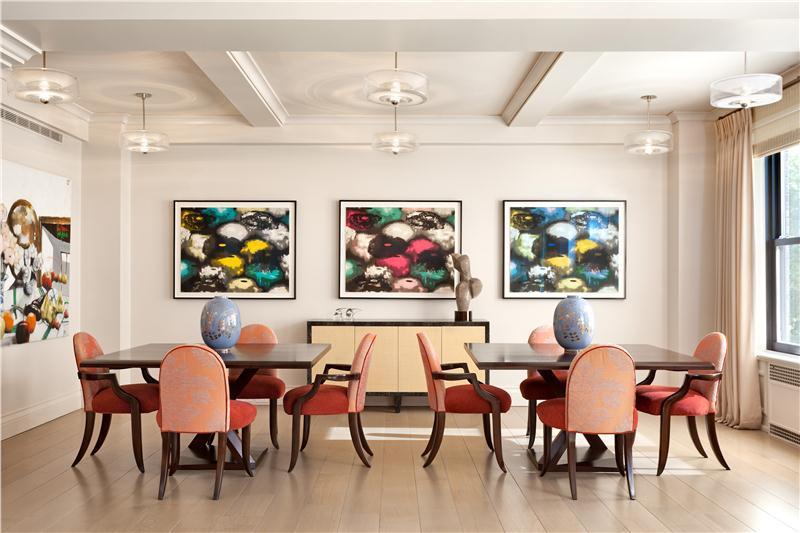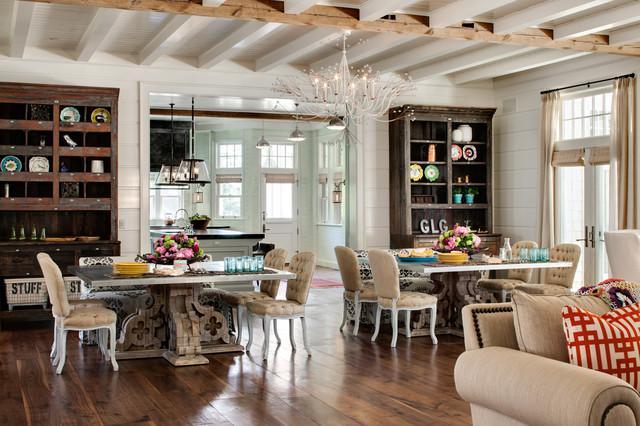The first image is the image on the left, the second image is the image on the right. Given the left and right images, does the statement "The right image shows two chandleliers suspended over a single table, and six chairs with curved legs are positioned by the table." hold true? Answer yes or no. No. 